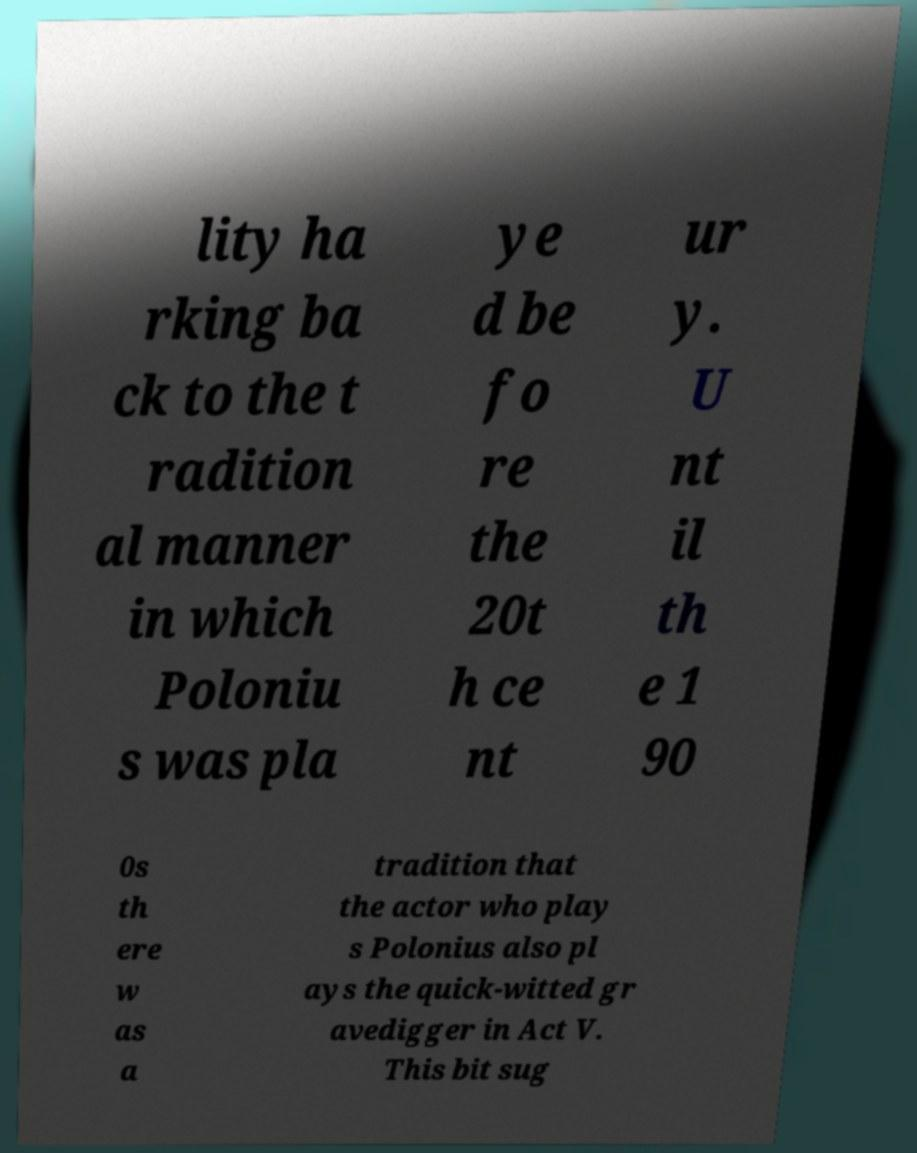Please read and relay the text visible in this image. What does it say? lity ha rking ba ck to the t radition al manner in which Poloniu s was pla ye d be fo re the 20t h ce nt ur y. U nt il th e 1 90 0s th ere w as a tradition that the actor who play s Polonius also pl ays the quick-witted gr avedigger in Act V. This bit sug 